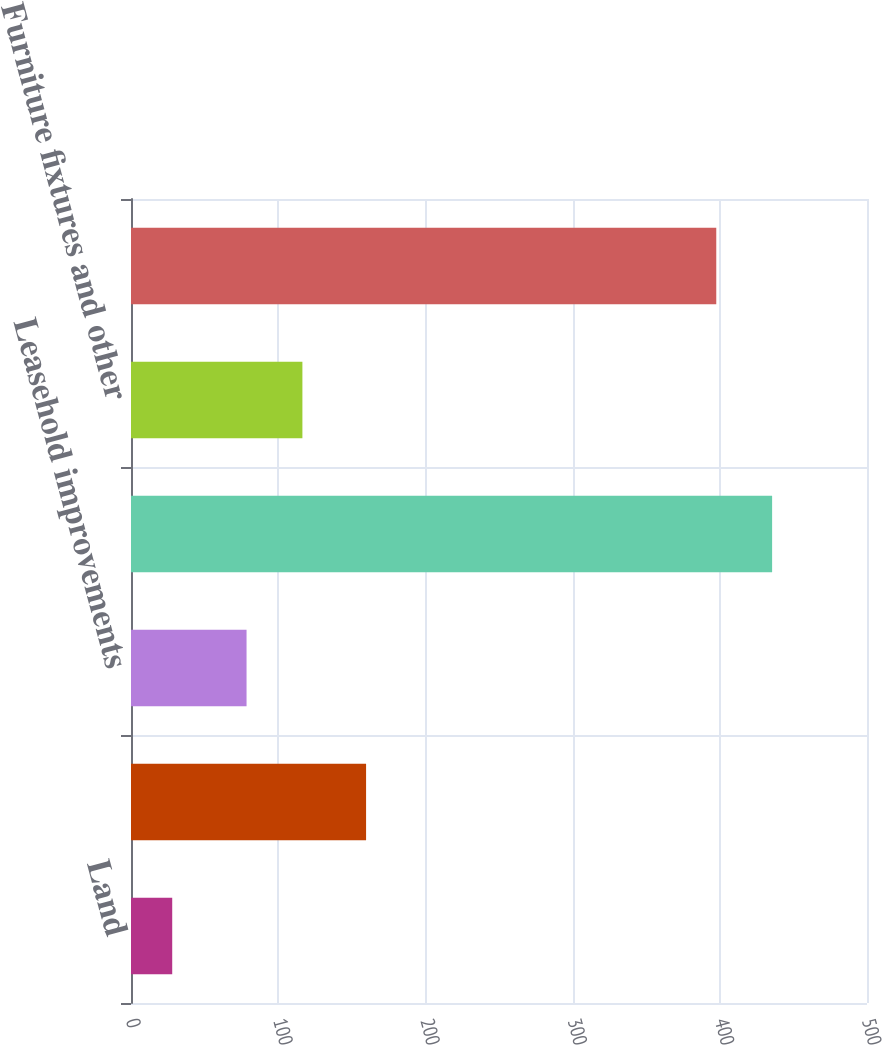Convert chart. <chart><loc_0><loc_0><loc_500><loc_500><bar_chart><fcel>Land<fcel>Buildings<fcel>Leasehold improvements<fcel>Computer equipment<fcel>Furniture fixtures and other<fcel>Accumulated depreciation and<nl><fcel>28<fcel>159.7<fcel>78.5<fcel>435.54<fcel>116.44<fcel>397.6<nl></chart> 